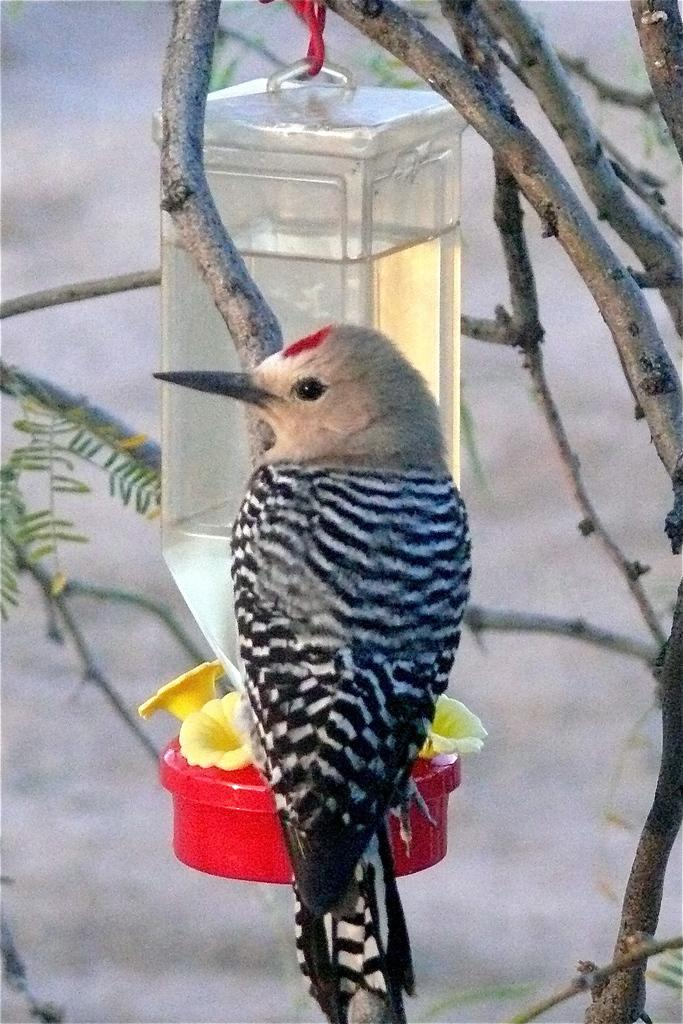What type of animal can be seen in the image? There is a bird in the image. Where is the bird located? The bird is on a branch of a tree. What else is present in the image besides the bird? There is a bottle in the image. What is inside the bottle? The bottle contains water. How is the bottle positioned in the image? The bottle is hung from a branch of a tree. How many mice are climbing on the bird's ear in the image? There are no mice present in the image, and the bird does not have any ears. 